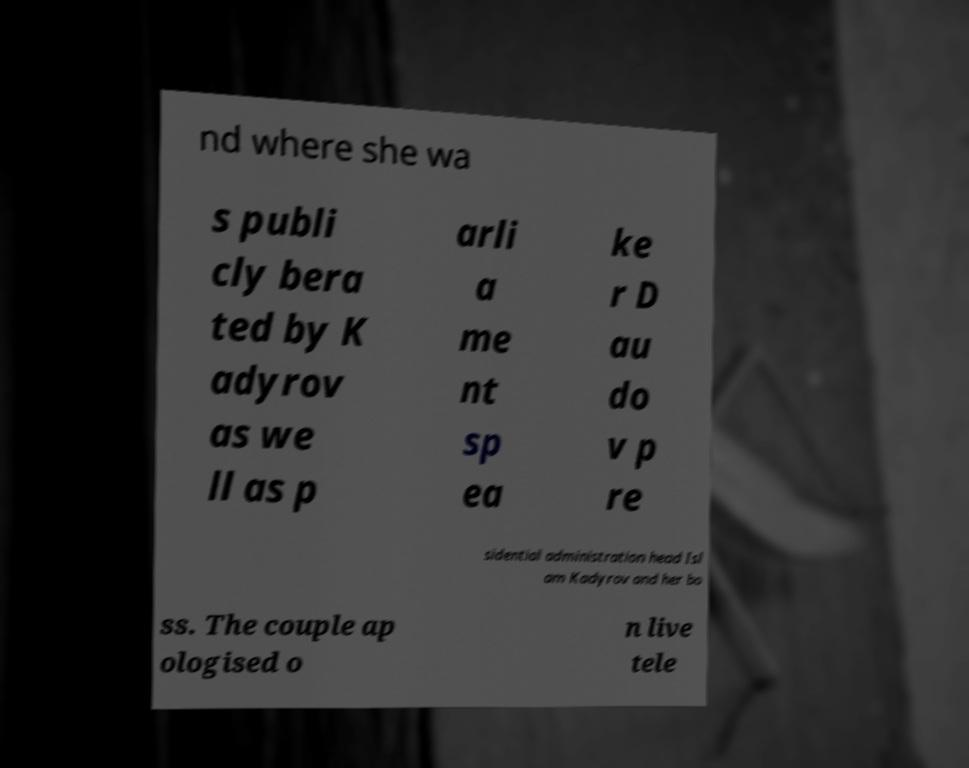Please read and relay the text visible in this image. What does it say? nd where she wa s publi cly bera ted by K adyrov as we ll as p arli a me nt sp ea ke r D au do v p re sidential administration head Isl am Kadyrov and her bo ss. The couple ap ologised o n live tele 